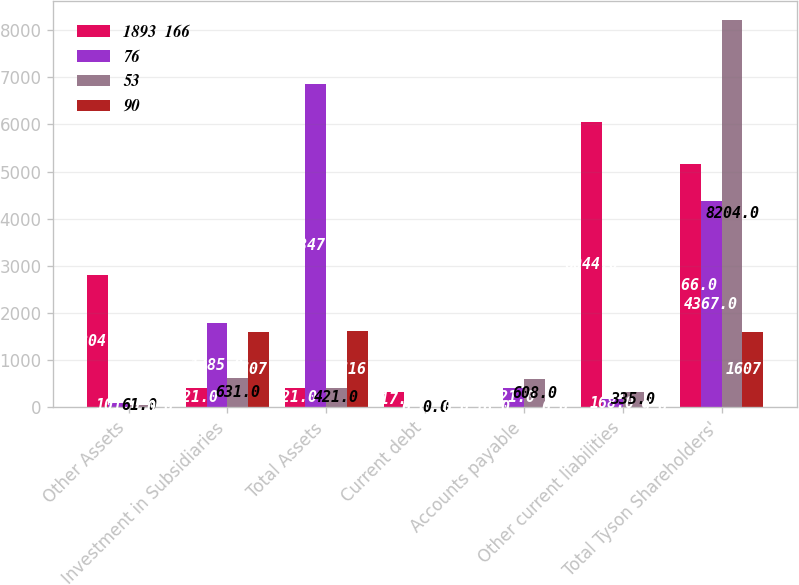Convert chart to OTSL. <chart><loc_0><loc_0><loc_500><loc_500><stacked_bar_chart><ecel><fcel>Other Assets<fcel>Investment in Subsidiaries<fcel>Total Assets<fcel>Current debt<fcel>Accounts payable<fcel>Other current liabilities<fcel>Total Tyson Shareholders'<nl><fcel>1893  166<fcel>2804<fcel>421<fcel>421<fcel>317<fcel>16<fcel>6044<fcel>5166<nl><fcel>76<fcel>101<fcel>1785<fcel>6847<fcel>0<fcel>421<fcel>168<fcel>4367<nl><fcel>53<fcel>61<fcel>631<fcel>421<fcel>0<fcel>608<fcel>335<fcel>8204<nl><fcel>90<fcel>0<fcel>1607<fcel>1616<fcel>0<fcel>0<fcel>9<fcel>1607<nl></chart> 